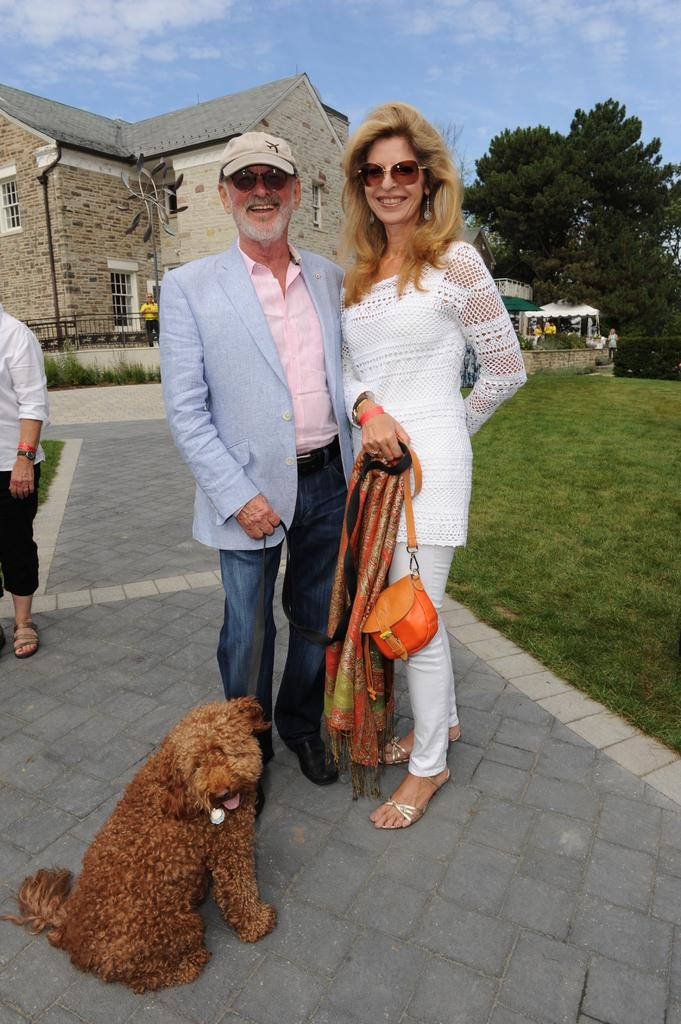How many people are in the image? There are two persons standing on the ground in the image. What is in front of the two persons? There is a dog in front of the two persons. What can be seen in the background of the image? There are trees, a building, and the sky visible in the background of the image. What type of sail can be seen on the dog in the image? There is no sail present on the dog in the image. 